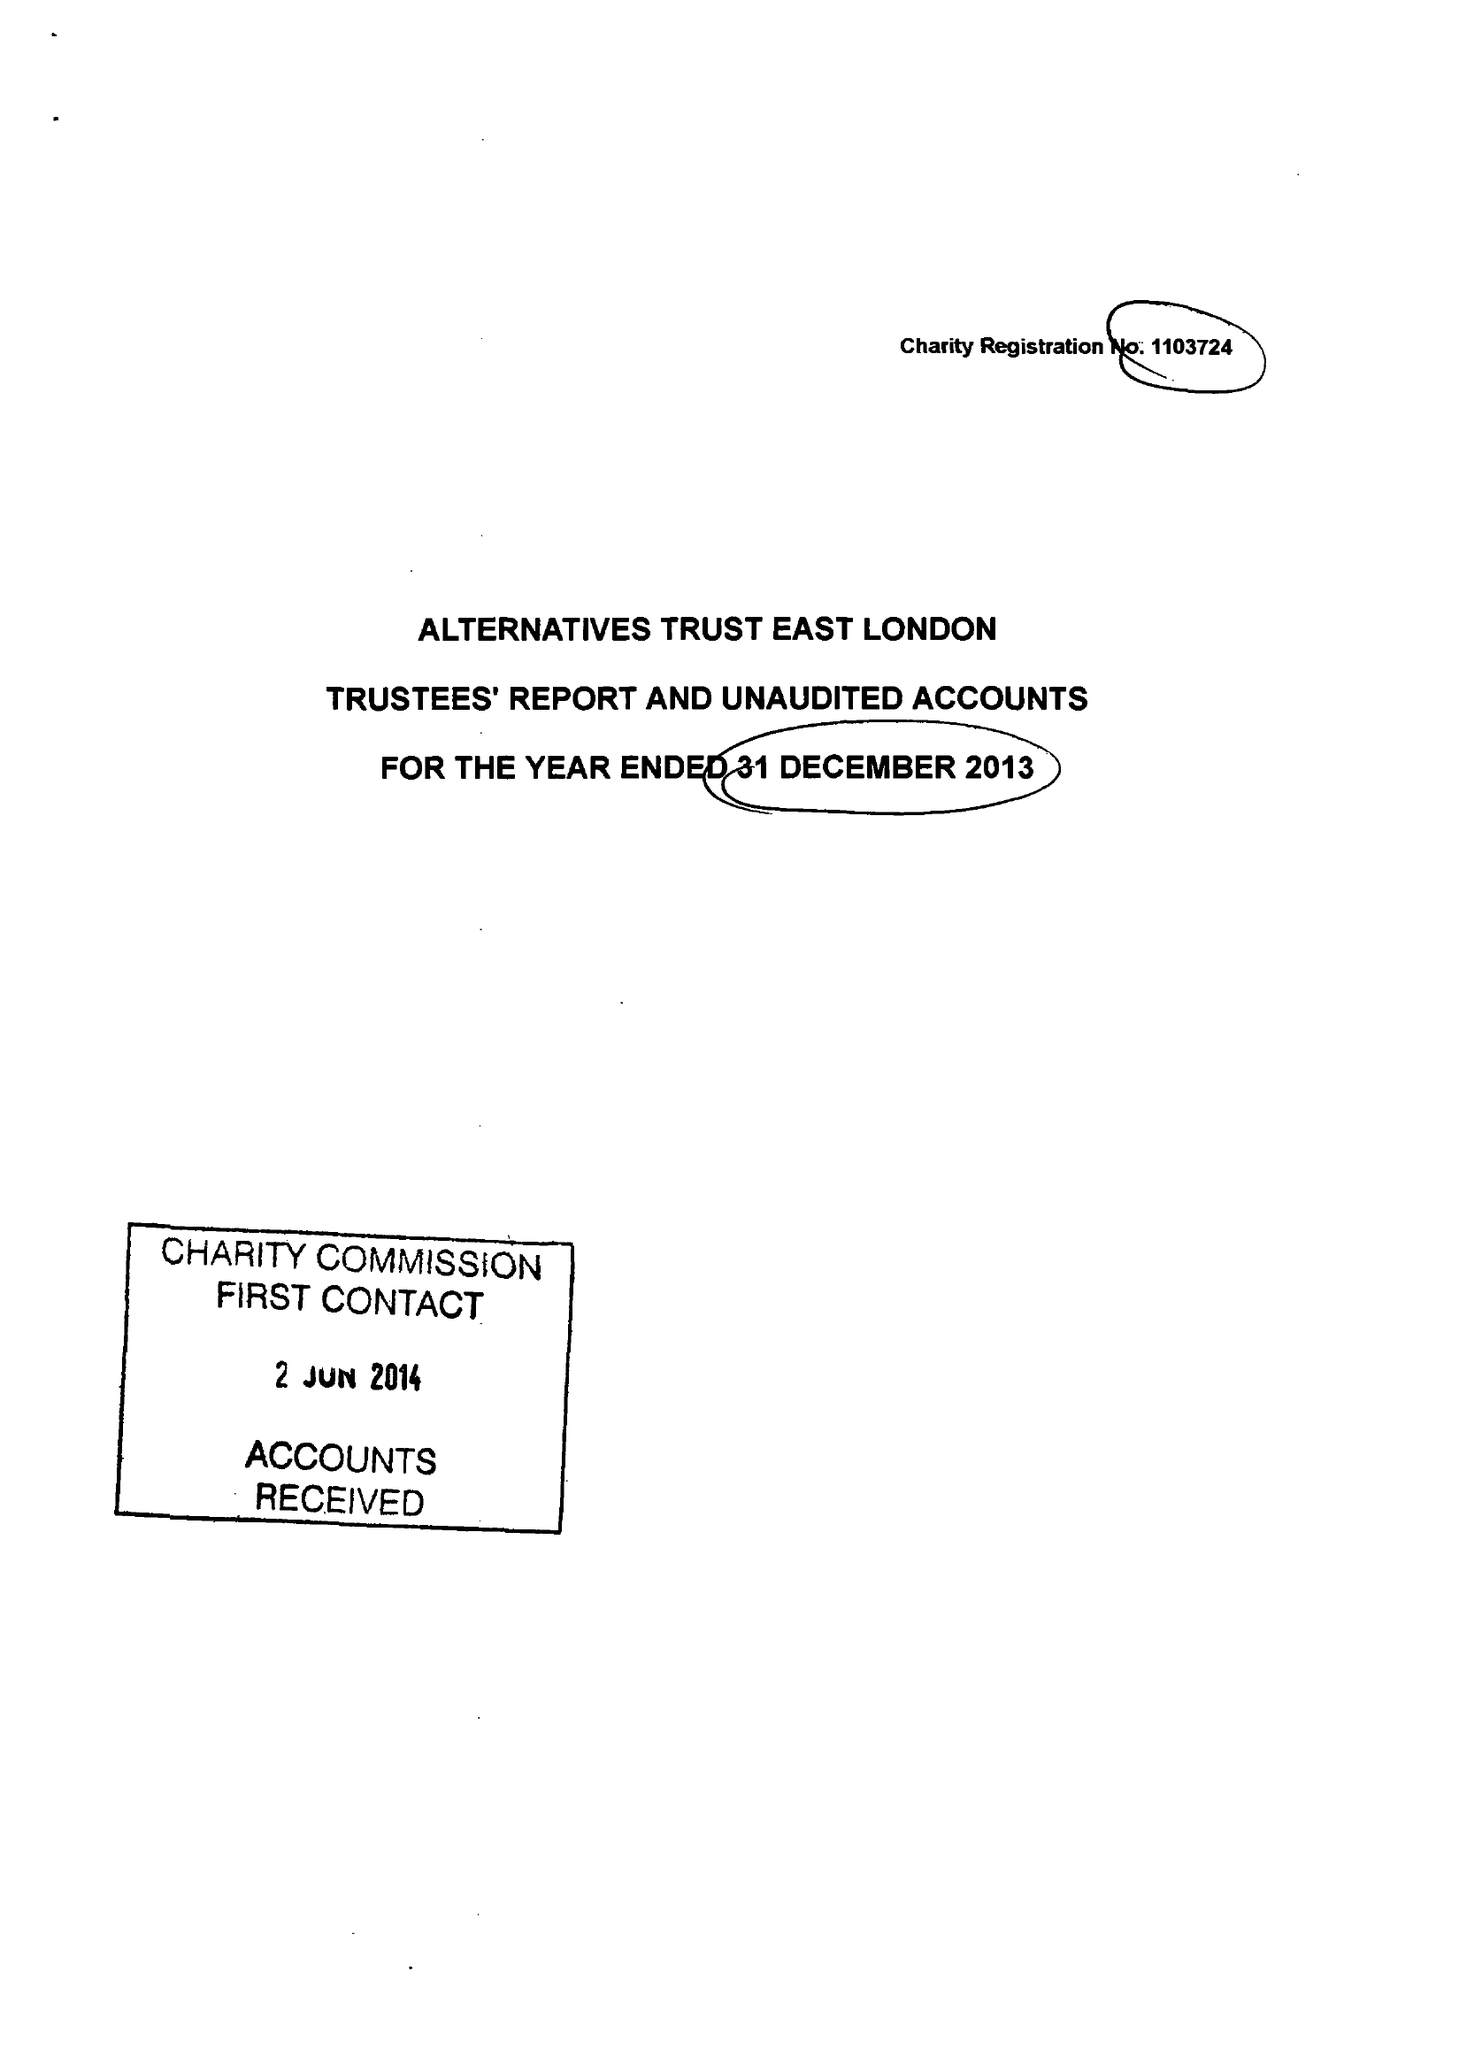What is the value for the spending_annually_in_british_pounds?
Answer the question using a single word or phrase. 114323.00 